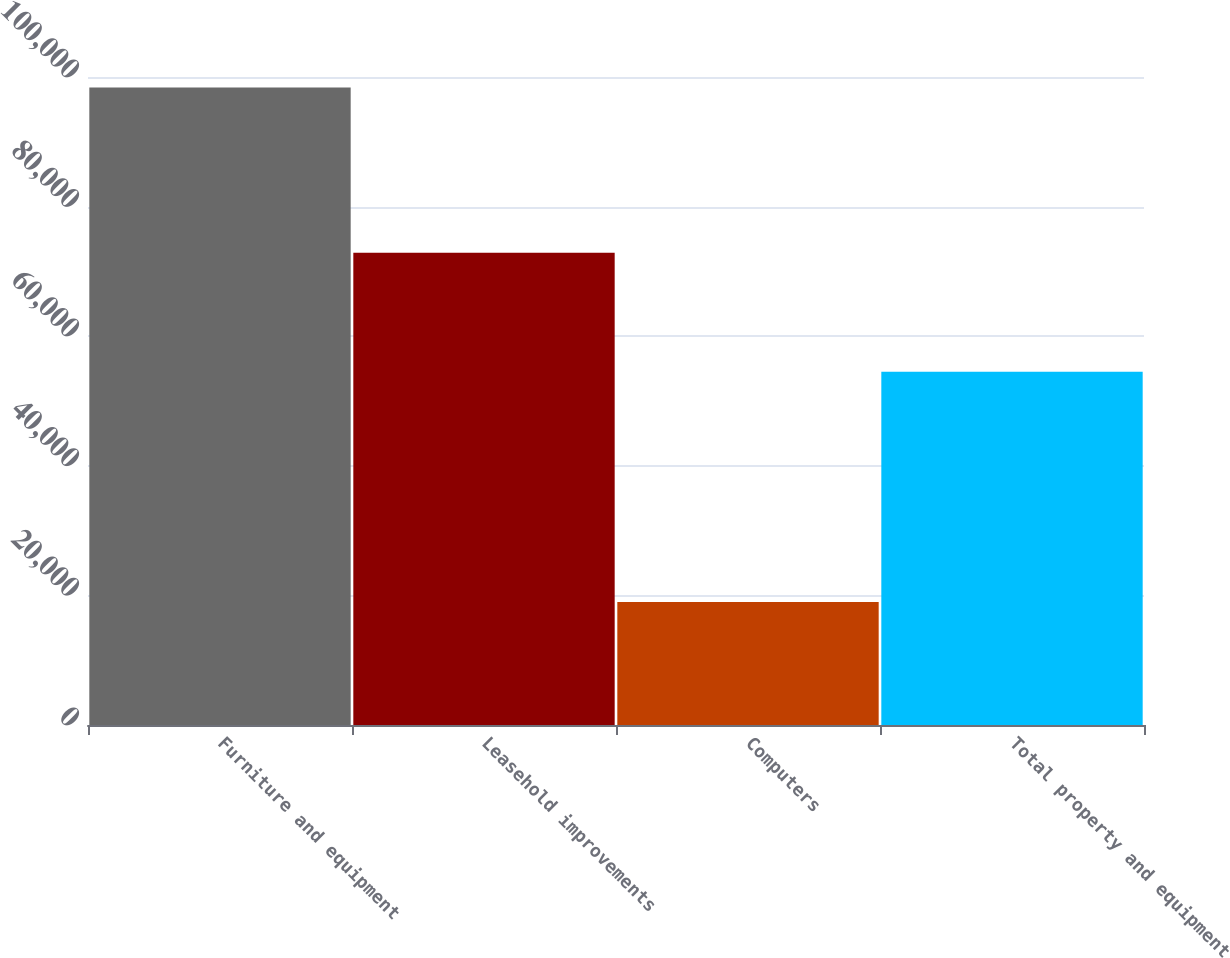Convert chart to OTSL. <chart><loc_0><loc_0><loc_500><loc_500><bar_chart><fcel>Furniture and equipment<fcel>Leasehold improvements<fcel>Computers<fcel>Total property and equipment<nl><fcel>98387<fcel>72871.8<fcel>18971<fcel>54533<nl></chart> 